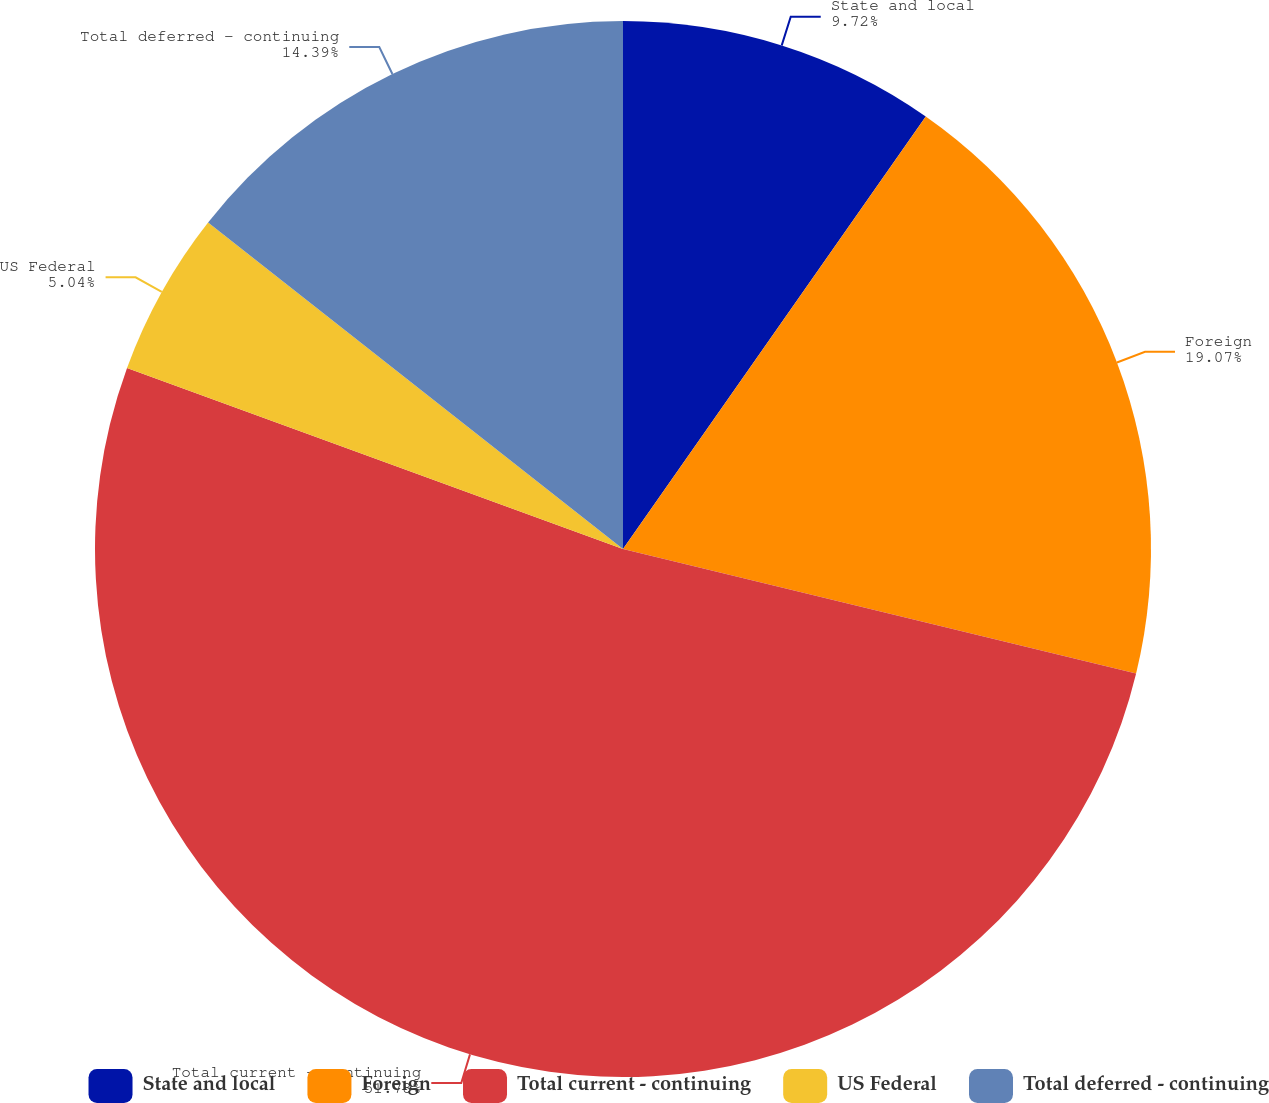Convert chart. <chart><loc_0><loc_0><loc_500><loc_500><pie_chart><fcel>State and local<fcel>Foreign<fcel>Total current - continuing<fcel>US Federal<fcel>Total deferred - continuing<nl><fcel>9.72%<fcel>19.07%<fcel>51.79%<fcel>5.04%<fcel>14.39%<nl></chart> 